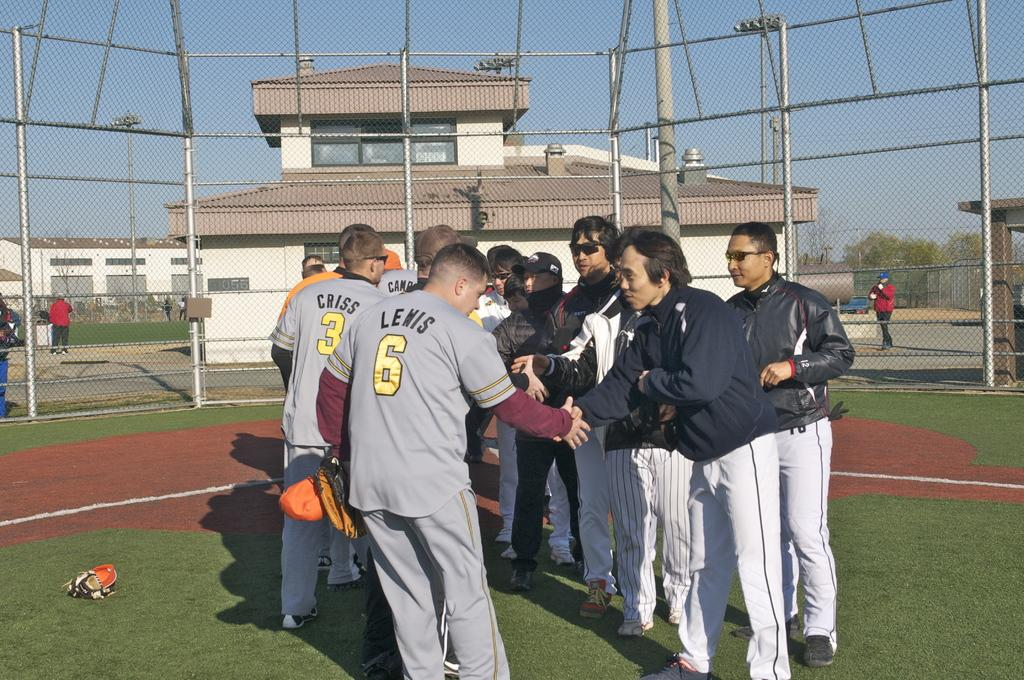<image>
Create a compact narrative representing the image presented. Mr. Lewis is shaking the hand of an opposing teams member. 